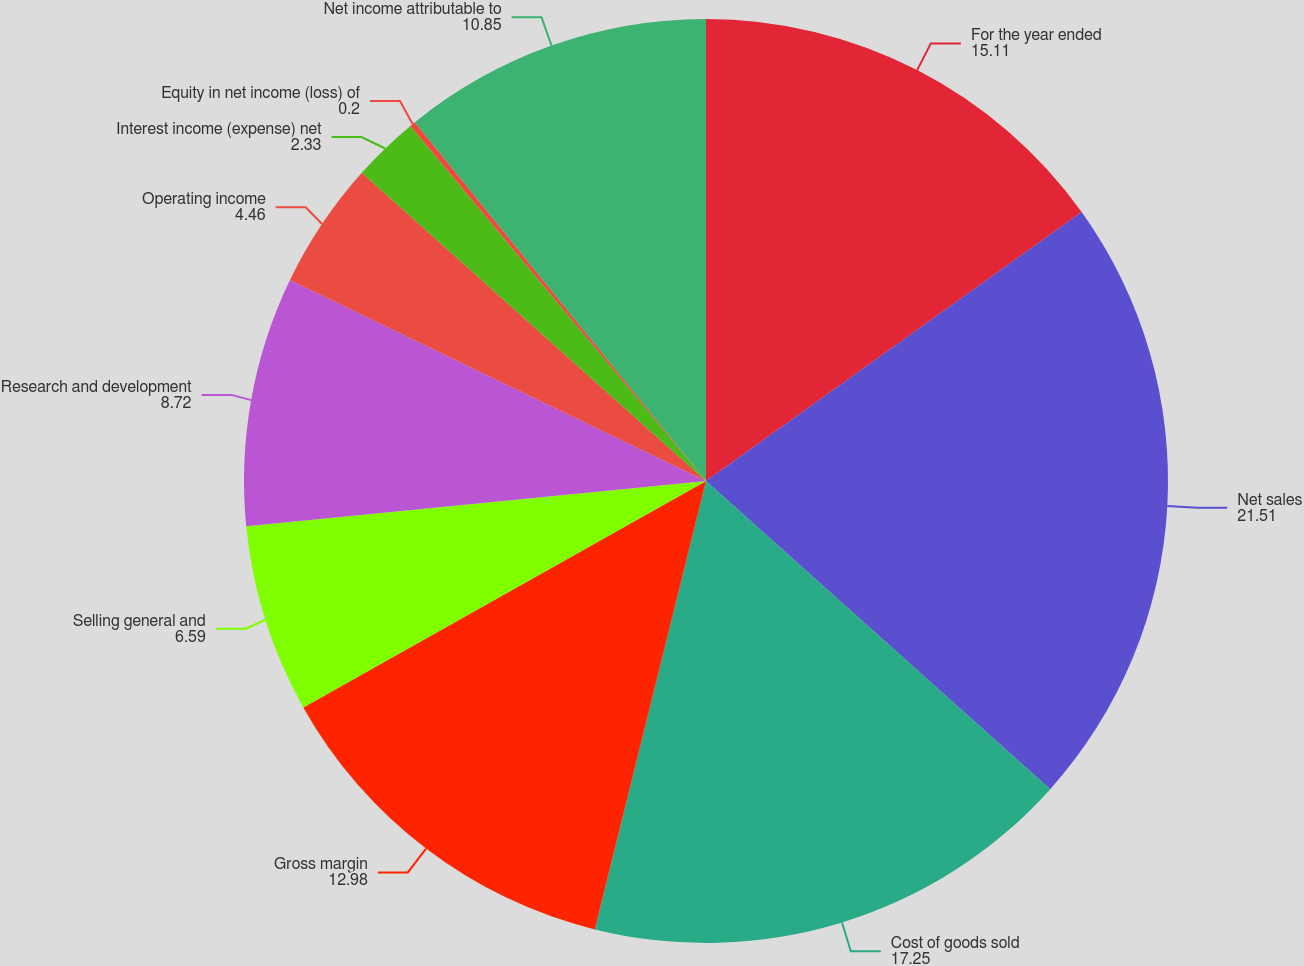Convert chart. <chart><loc_0><loc_0><loc_500><loc_500><pie_chart><fcel>For the year ended<fcel>Net sales<fcel>Cost of goods sold<fcel>Gross margin<fcel>Selling general and<fcel>Research and development<fcel>Operating income<fcel>Interest income (expense) net<fcel>Equity in net income (loss) of<fcel>Net income attributable to<nl><fcel>15.11%<fcel>21.51%<fcel>17.25%<fcel>12.98%<fcel>6.59%<fcel>8.72%<fcel>4.46%<fcel>2.33%<fcel>0.2%<fcel>10.85%<nl></chart> 